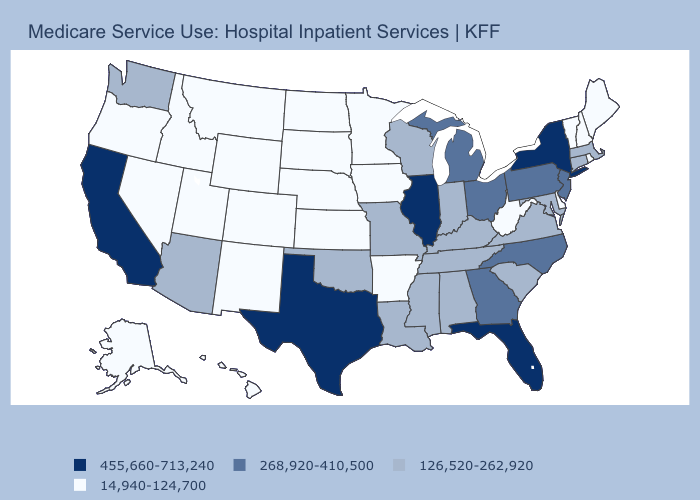Which states hav the highest value in the Northeast?
Quick response, please. New York. Name the states that have a value in the range 126,520-262,920?
Quick response, please. Alabama, Arizona, Connecticut, Indiana, Kentucky, Louisiana, Maryland, Massachusetts, Mississippi, Missouri, Oklahoma, South Carolina, Tennessee, Virginia, Washington, Wisconsin. Which states have the highest value in the USA?
Keep it brief. California, Florida, Illinois, New York, Texas. What is the value of Mississippi?
Give a very brief answer. 126,520-262,920. What is the value of New York?
Concise answer only. 455,660-713,240. What is the value of Florida?
Give a very brief answer. 455,660-713,240. Name the states that have a value in the range 126,520-262,920?
Short answer required. Alabama, Arizona, Connecticut, Indiana, Kentucky, Louisiana, Maryland, Massachusetts, Mississippi, Missouri, Oklahoma, South Carolina, Tennessee, Virginia, Washington, Wisconsin. Name the states that have a value in the range 14,940-124,700?
Write a very short answer. Alaska, Arkansas, Colorado, Delaware, Hawaii, Idaho, Iowa, Kansas, Maine, Minnesota, Montana, Nebraska, Nevada, New Hampshire, New Mexico, North Dakota, Oregon, Rhode Island, South Dakota, Utah, Vermont, West Virginia, Wyoming. Name the states that have a value in the range 126,520-262,920?
Answer briefly. Alabama, Arizona, Connecticut, Indiana, Kentucky, Louisiana, Maryland, Massachusetts, Mississippi, Missouri, Oklahoma, South Carolina, Tennessee, Virginia, Washington, Wisconsin. Name the states that have a value in the range 126,520-262,920?
Give a very brief answer. Alabama, Arizona, Connecticut, Indiana, Kentucky, Louisiana, Maryland, Massachusetts, Mississippi, Missouri, Oklahoma, South Carolina, Tennessee, Virginia, Washington, Wisconsin. What is the lowest value in the USA?
Concise answer only. 14,940-124,700. Does Georgia have a lower value than Connecticut?
Write a very short answer. No. What is the value of Washington?
Concise answer only. 126,520-262,920. Which states have the lowest value in the USA?
Short answer required. Alaska, Arkansas, Colorado, Delaware, Hawaii, Idaho, Iowa, Kansas, Maine, Minnesota, Montana, Nebraska, Nevada, New Hampshire, New Mexico, North Dakota, Oregon, Rhode Island, South Dakota, Utah, Vermont, West Virginia, Wyoming. 